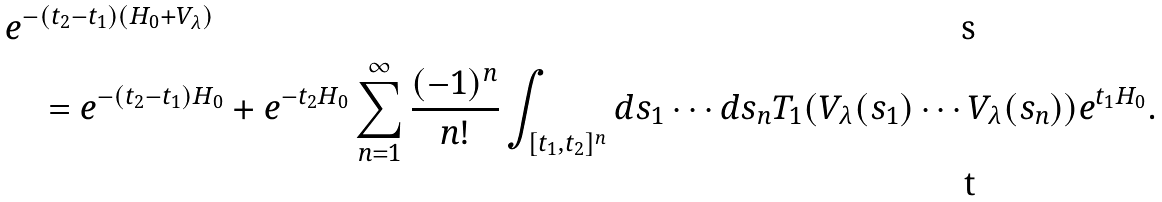<formula> <loc_0><loc_0><loc_500><loc_500>& e ^ { - ( t _ { 2 } - t _ { 1 } ) ( H _ { 0 } + V _ { \lambda } ) } \\ & \quad = e ^ { - ( t _ { 2 } - t _ { 1 } ) H _ { 0 } } + e ^ { - t _ { 2 } H _ { 0 } } \sum _ { n = 1 } ^ { \infty } \frac { ( - 1 ) ^ { n } } { n ! } \int _ { [ t _ { 1 } , t _ { 2 } ] ^ { n } } d s _ { 1 } \cdots d s _ { n } T _ { 1 } ( V _ { \lambda } ( s _ { 1 } ) \cdots V _ { \lambda } ( s _ { n } ) ) e ^ { t _ { 1 } H _ { 0 } } .</formula> 